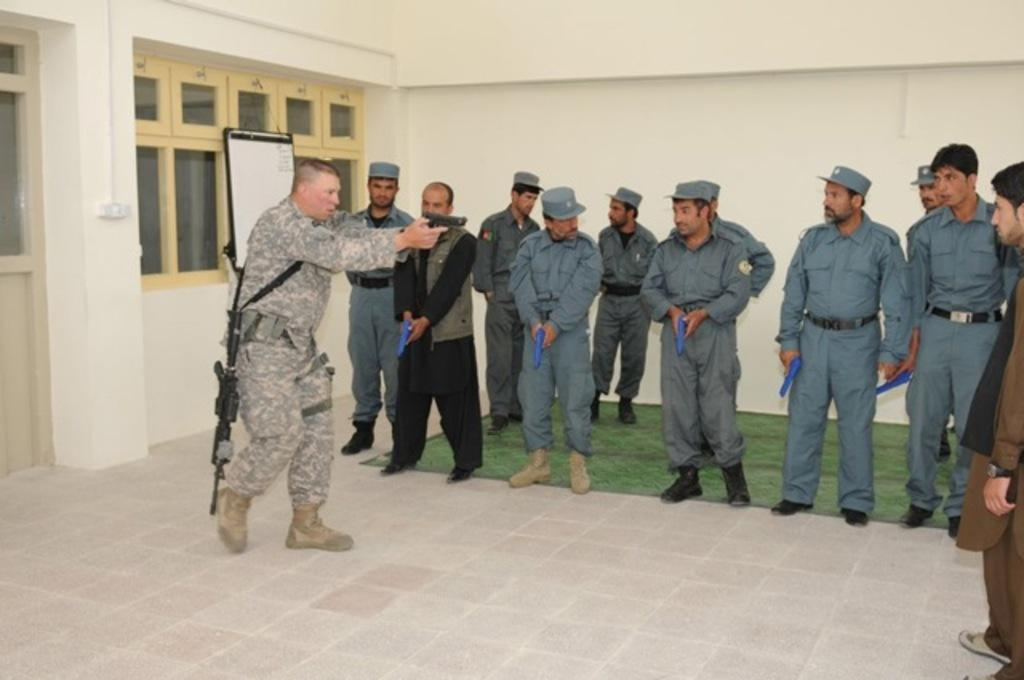What are the people in the image wearing? The people in the image are wearing uniforms. What are the people holding in the image? The people are holding guns. What can be seen in the background of the image? There is a board, windows, a door, and a wall in the background of the image. Can you tell me how many people are helping to kick the ball in the image? There is no ball or activity involving kicking in the image. 